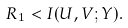Convert formula to latex. <formula><loc_0><loc_0><loc_500><loc_500>R _ { 1 } < I ( U , V ; Y ) .</formula> 